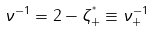Convert formula to latex. <formula><loc_0><loc_0><loc_500><loc_500>\nu ^ { - 1 } = 2 - \zeta _ { + } ^ { ^ { * } } \equiv \nu _ { + } ^ { - 1 }</formula> 